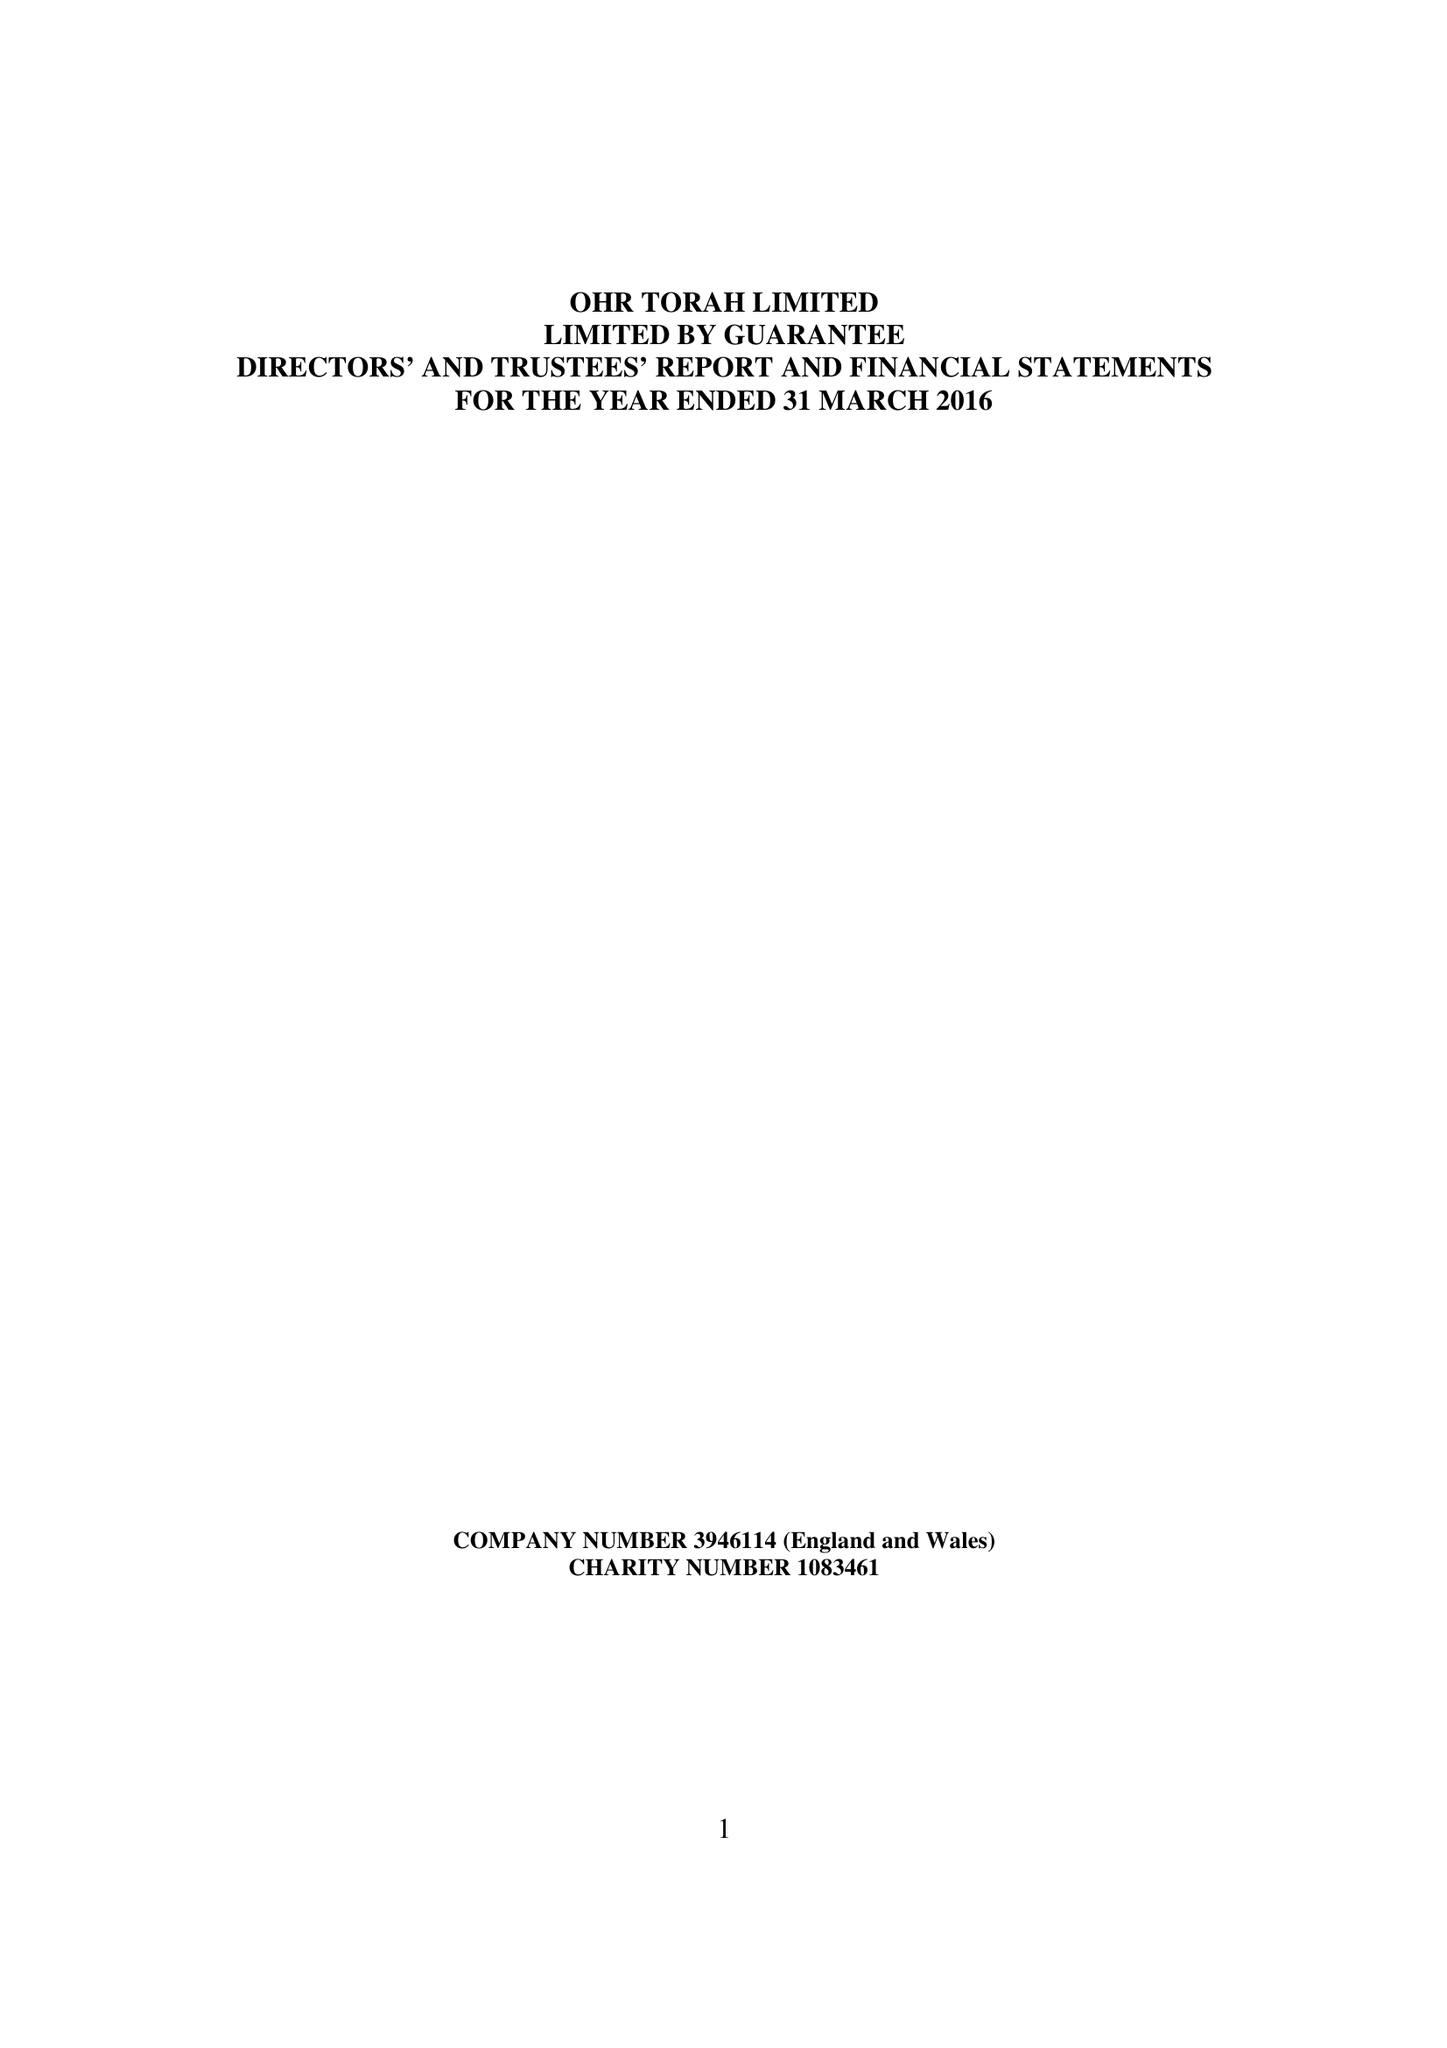What is the value for the address__postcode?
Answer the question using a single word or phrase. M8 5DT 